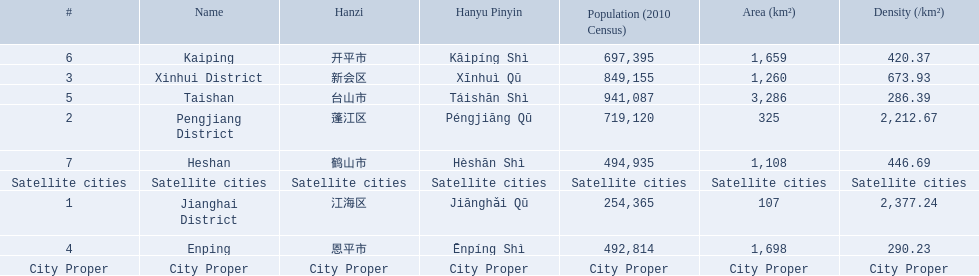What city propers are listed? Jianghai District, Pengjiang District, Xinhui District. Which hast he smallest area in km2? Jianghai District. 